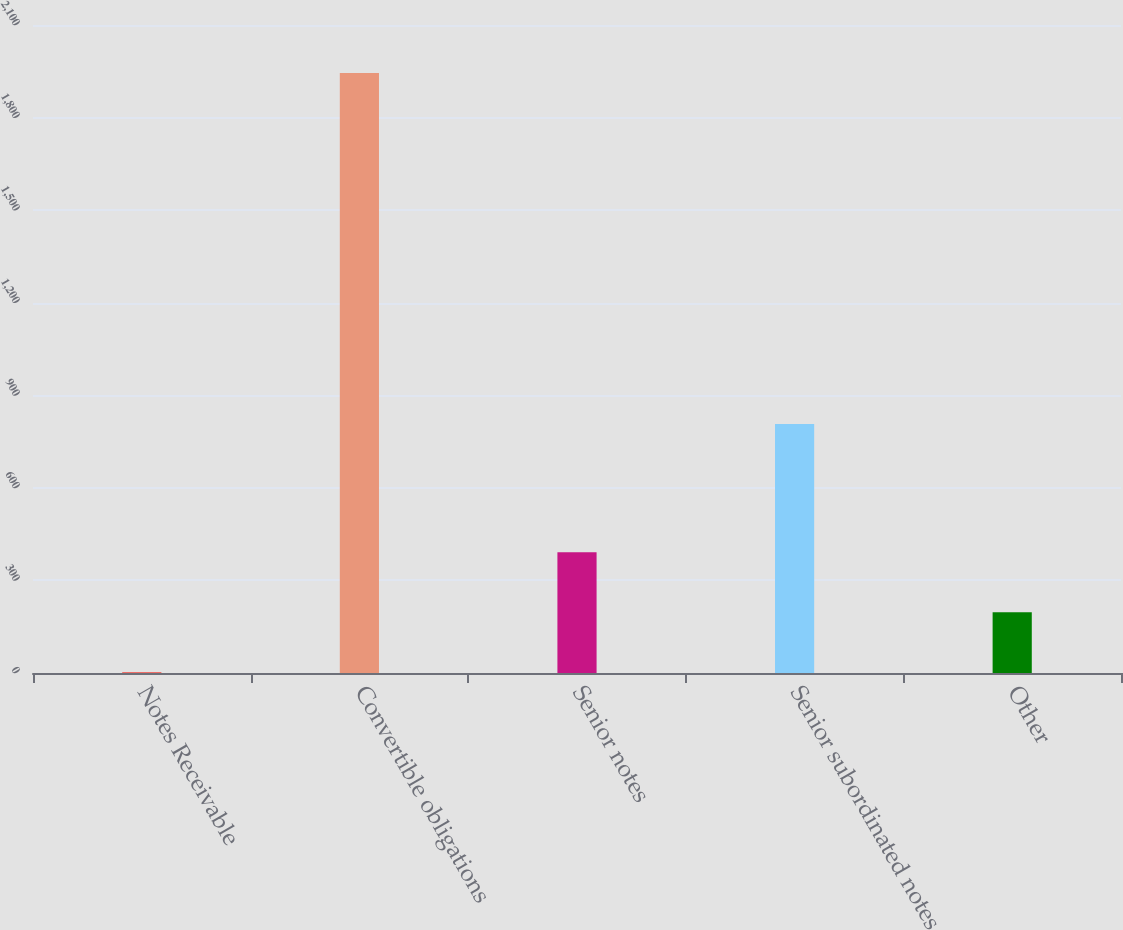Convert chart. <chart><loc_0><loc_0><loc_500><loc_500><bar_chart><fcel>Notes Receivable<fcel>Convertible obligations<fcel>Senior notes<fcel>Senior subordinated notes<fcel>Other<nl><fcel>2.6<fcel>1944.3<fcel>390.94<fcel>806.6<fcel>196.77<nl></chart> 